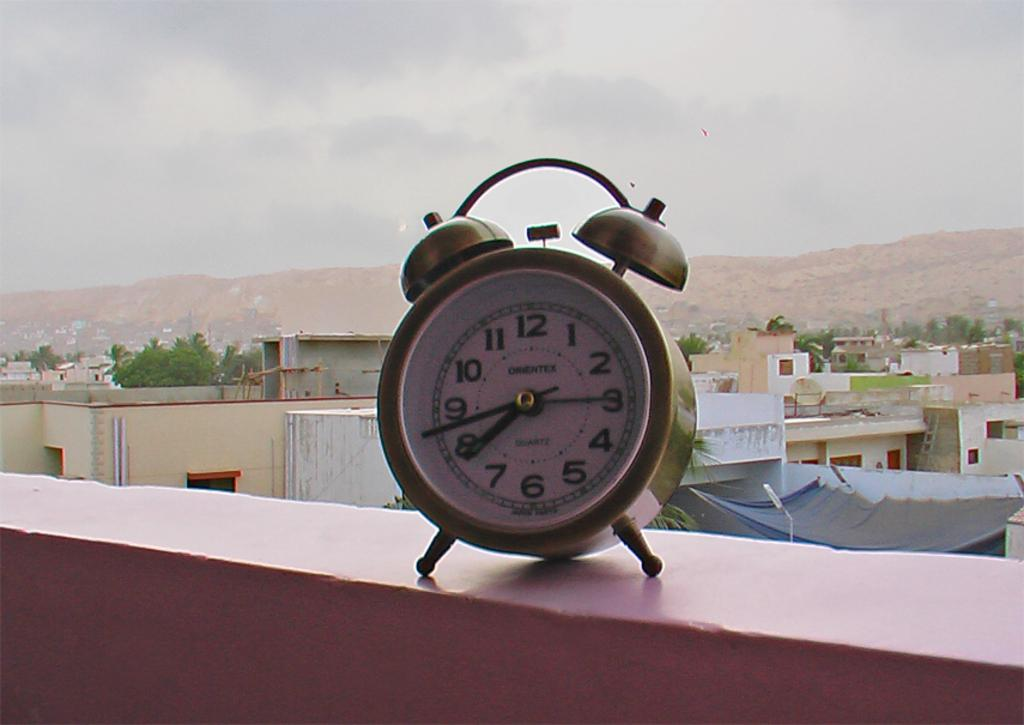<image>
Provide a brief description of the given image. A Quartz two bell alarm clock sitting on a shelf facing a city landscape. 